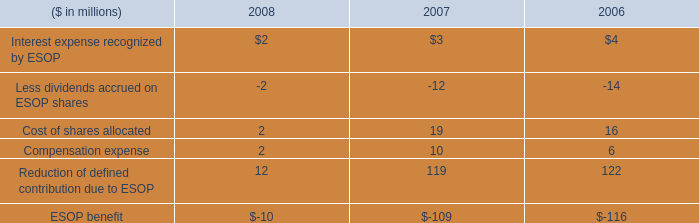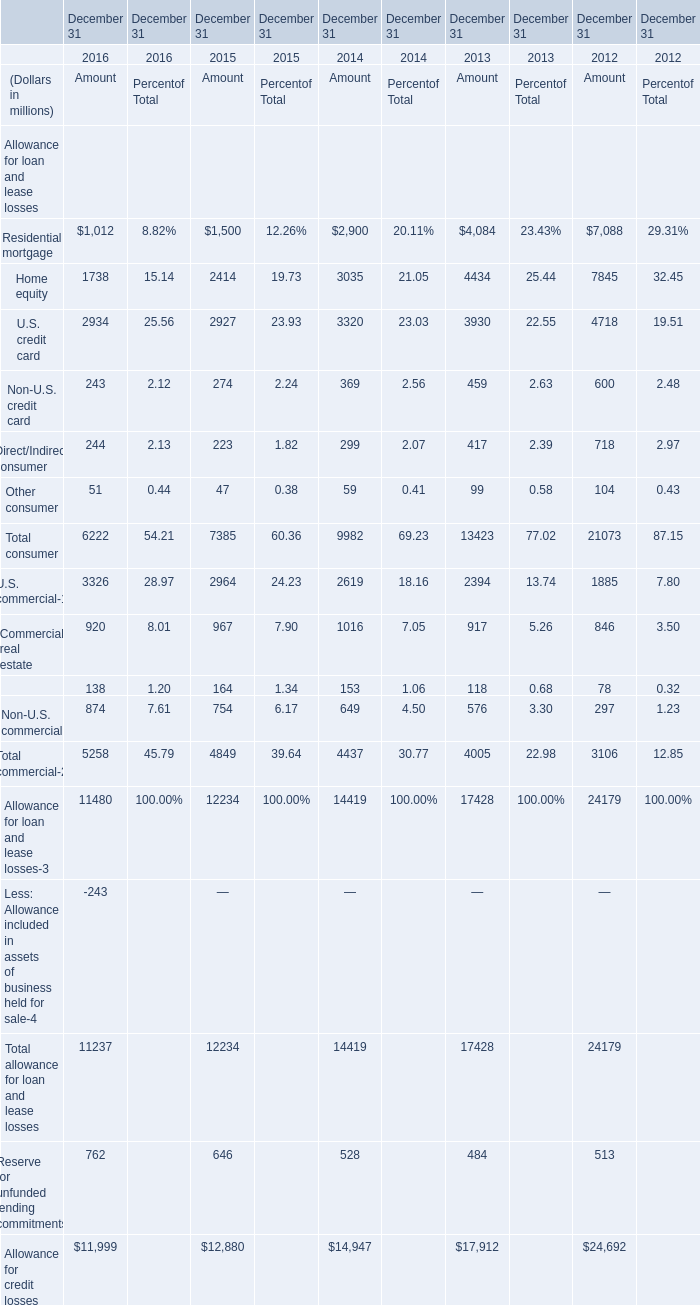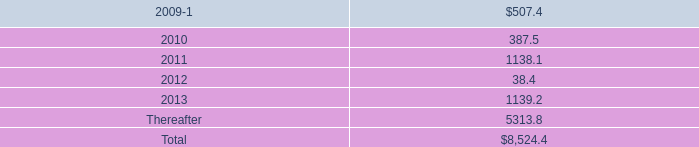In the year with largest amount of Residential mortgage, what's the sum of U.S. credit card and Non-U.S. credit card ? (in million) 
Computations: (4718 + 600)
Answer: 5318.0. 